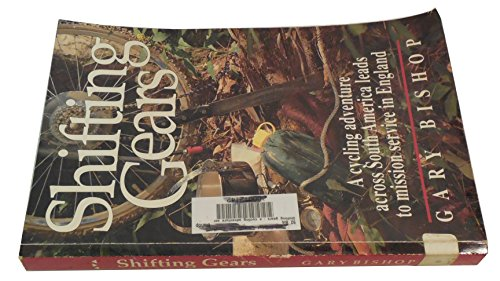What type of book is this? This is a travel book, focusing on a unique cycling adventure across South America and extending into duties in mission service in England. 